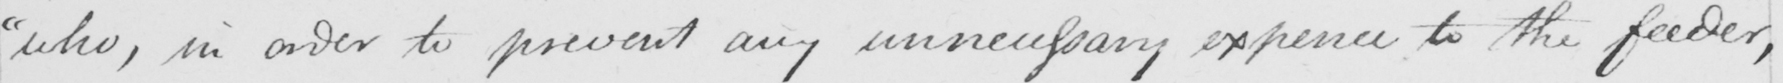What text is written in this handwritten line? "who, in order to prevent any unnecessary expence to the feeder, 